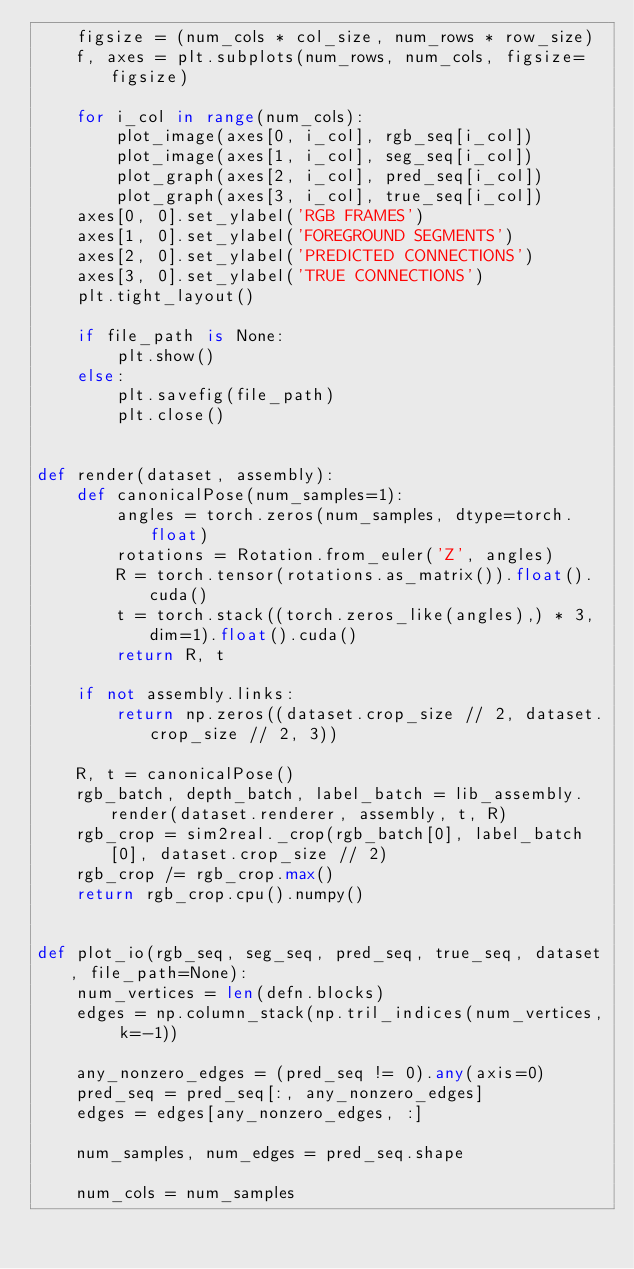<code> <loc_0><loc_0><loc_500><loc_500><_Python_>    figsize = (num_cols * col_size, num_rows * row_size)
    f, axes = plt.subplots(num_rows, num_cols, figsize=figsize)

    for i_col in range(num_cols):
        plot_image(axes[0, i_col], rgb_seq[i_col])
        plot_image(axes[1, i_col], seg_seq[i_col])
        plot_graph(axes[2, i_col], pred_seq[i_col])
        plot_graph(axes[3, i_col], true_seq[i_col])
    axes[0, 0].set_ylabel('RGB FRAMES')
    axes[1, 0].set_ylabel('FOREGROUND SEGMENTS')
    axes[2, 0].set_ylabel('PREDICTED CONNECTIONS')
    axes[3, 0].set_ylabel('TRUE CONNECTIONS')
    plt.tight_layout()

    if file_path is None:
        plt.show()
    else:
        plt.savefig(file_path)
        plt.close()


def render(dataset, assembly):
    def canonicalPose(num_samples=1):
        angles = torch.zeros(num_samples, dtype=torch.float)
        rotations = Rotation.from_euler('Z', angles)
        R = torch.tensor(rotations.as_matrix()).float().cuda()
        t = torch.stack((torch.zeros_like(angles),) * 3, dim=1).float().cuda()
        return R, t

    if not assembly.links:
        return np.zeros((dataset.crop_size // 2, dataset.crop_size // 2, 3))

    R, t = canonicalPose()
    rgb_batch, depth_batch, label_batch = lib_assembly.render(dataset.renderer, assembly, t, R)
    rgb_crop = sim2real._crop(rgb_batch[0], label_batch[0], dataset.crop_size // 2)
    rgb_crop /= rgb_crop.max()
    return rgb_crop.cpu().numpy()


def plot_io(rgb_seq, seg_seq, pred_seq, true_seq, dataset, file_path=None):
    num_vertices = len(defn.blocks)
    edges = np.column_stack(np.tril_indices(num_vertices, k=-1))

    any_nonzero_edges = (pred_seq != 0).any(axis=0)
    pred_seq = pred_seq[:, any_nonzero_edges]
    edges = edges[any_nonzero_edges, :]

    num_samples, num_edges = pred_seq.shape

    num_cols = num_samples</code> 